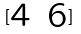<formula> <loc_0><loc_0><loc_500><loc_500>[ \begin{matrix} 4 & 6 \end{matrix} ]</formula> 